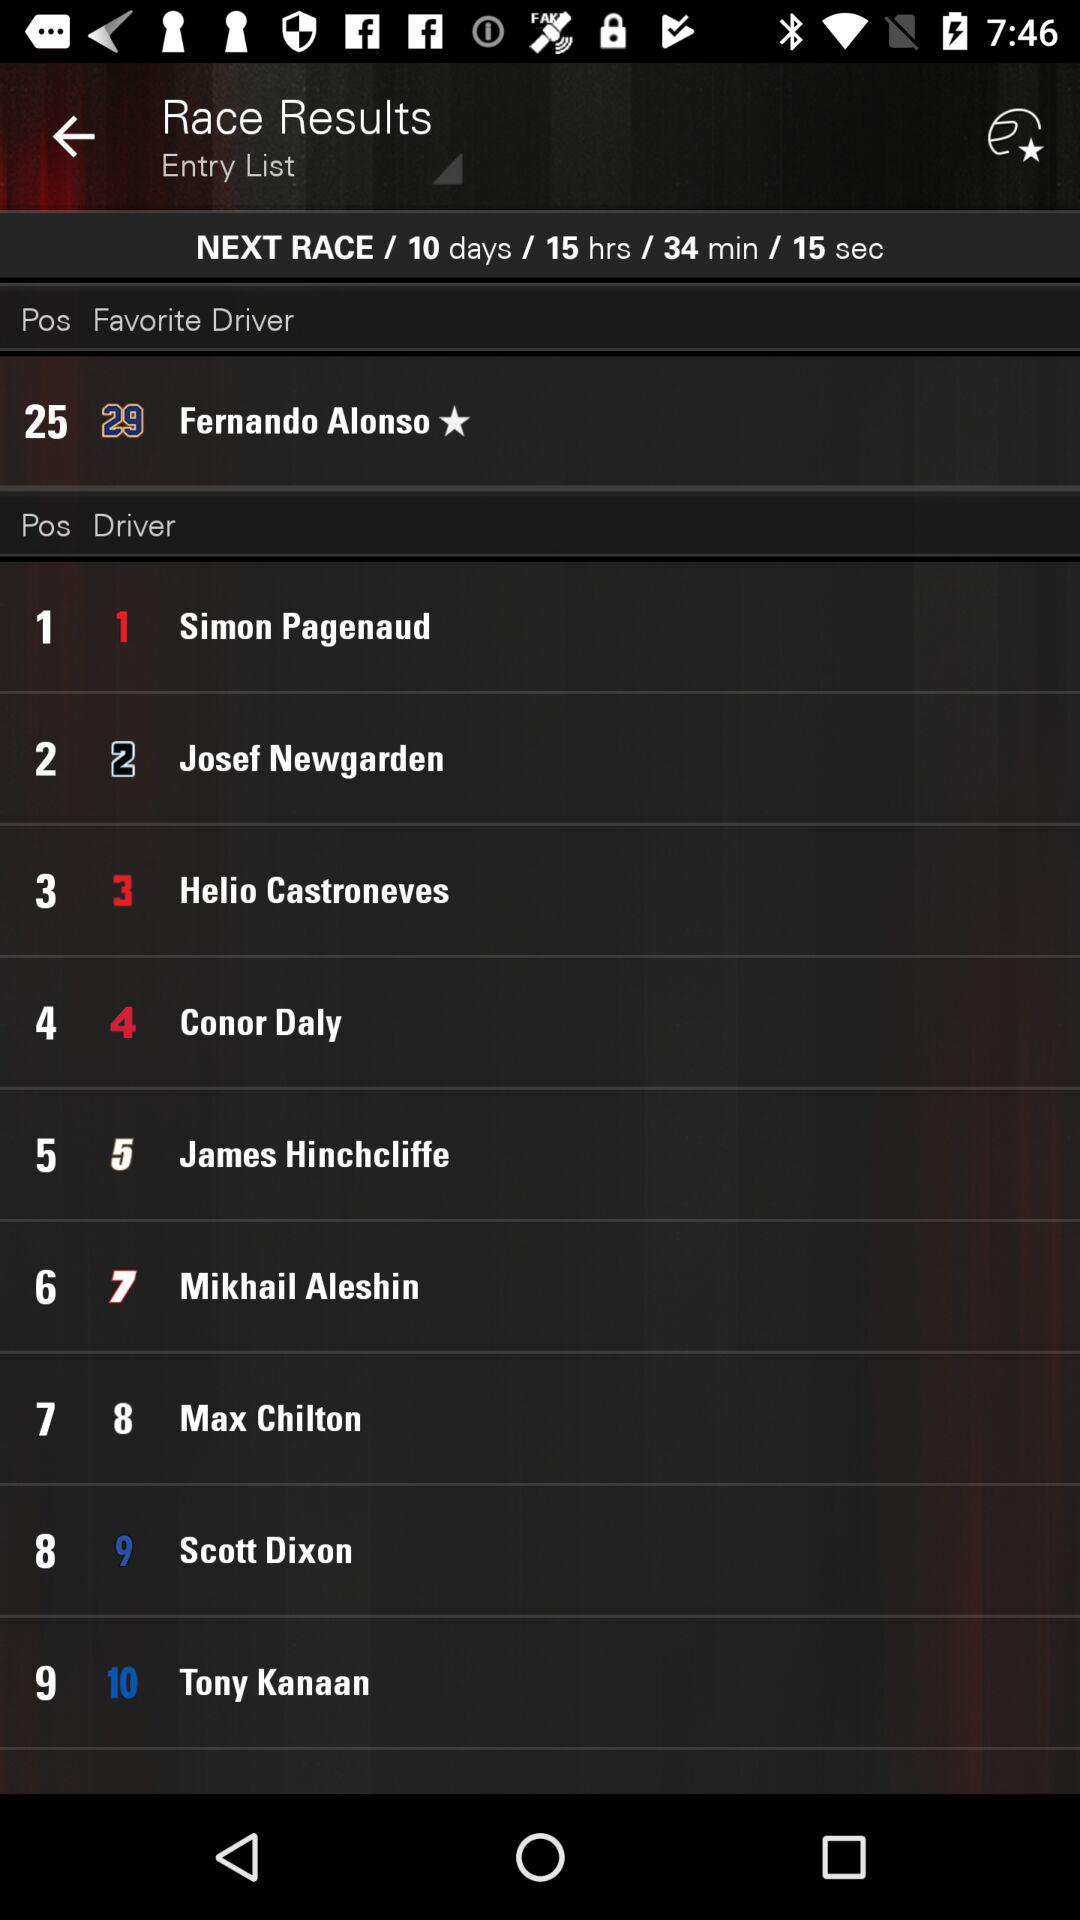Who is the favourite driver? The favourite driver is Fernando Alonso. 